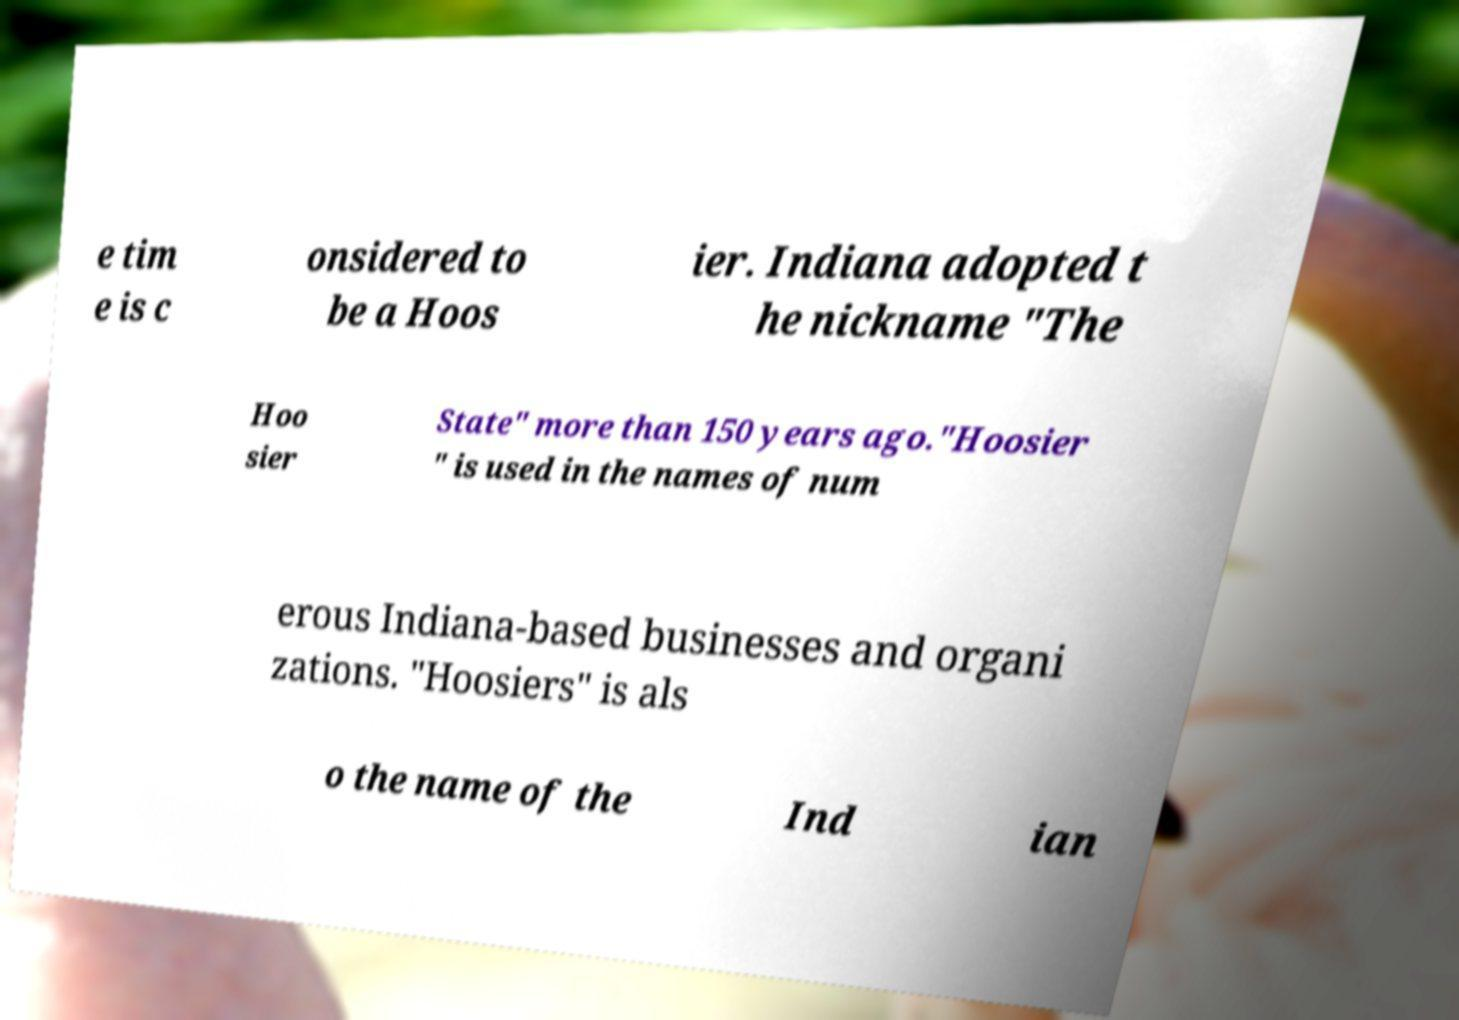Please read and relay the text visible in this image. What does it say? e tim e is c onsidered to be a Hoos ier. Indiana adopted t he nickname "The Hoo sier State" more than 150 years ago."Hoosier " is used in the names of num erous Indiana-based businesses and organi zations. "Hoosiers" is als o the name of the Ind ian 